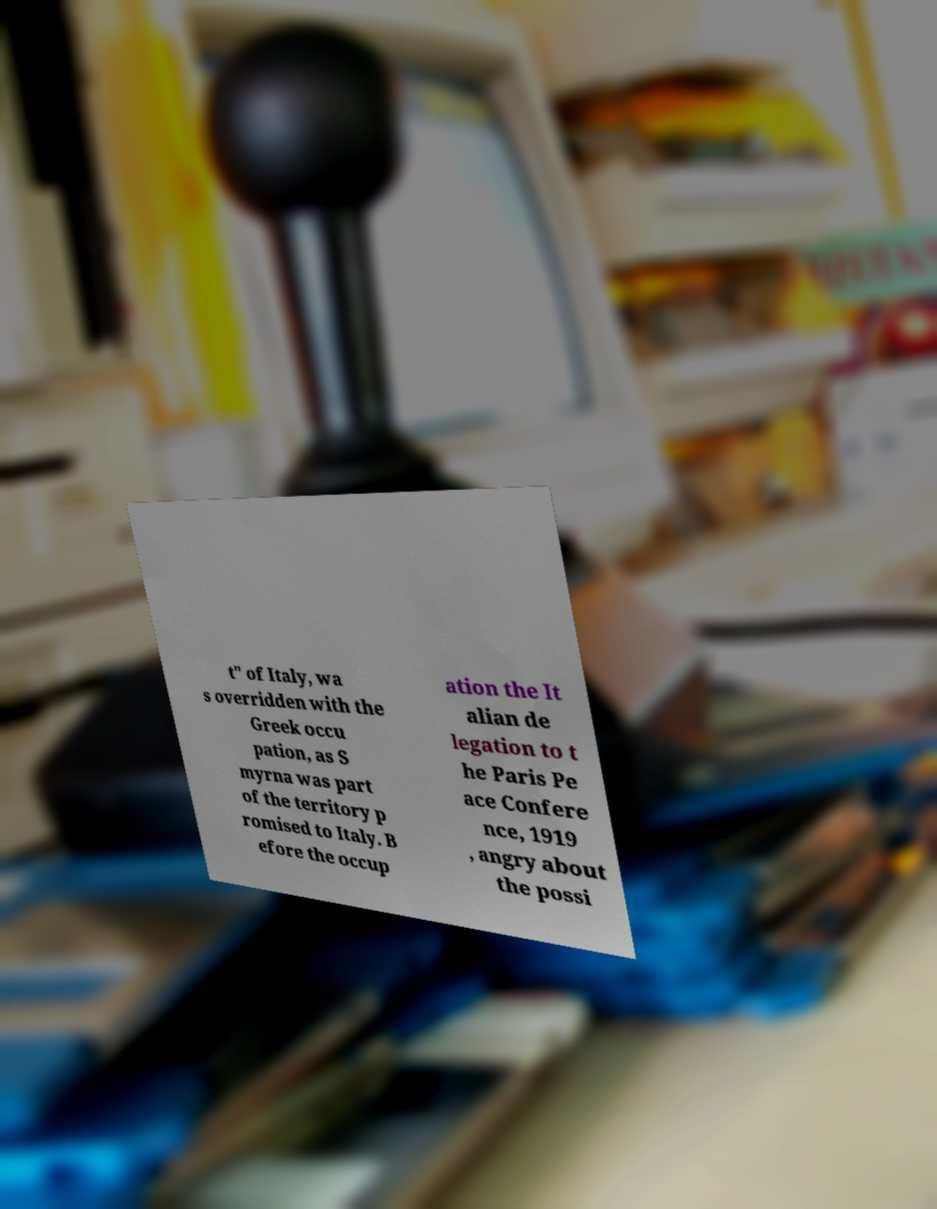There's text embedded in this image that I need extracted. Can you transcribe it verbatim? t" of Italy, wa s overridden with the Greek occu pation, as S myrna was part of the territory p romised to Italy. B efore the occup ation the It alian de legation to t he Paris Pe ace Confere nce, 1919 , angry about the possi 